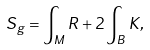Convert formula to latex. <formula><loc_0><loc_0><loc_500><loc_500>S _ { g } = \int _ { M } R + 2 \int _ { B } K ,</formula> 